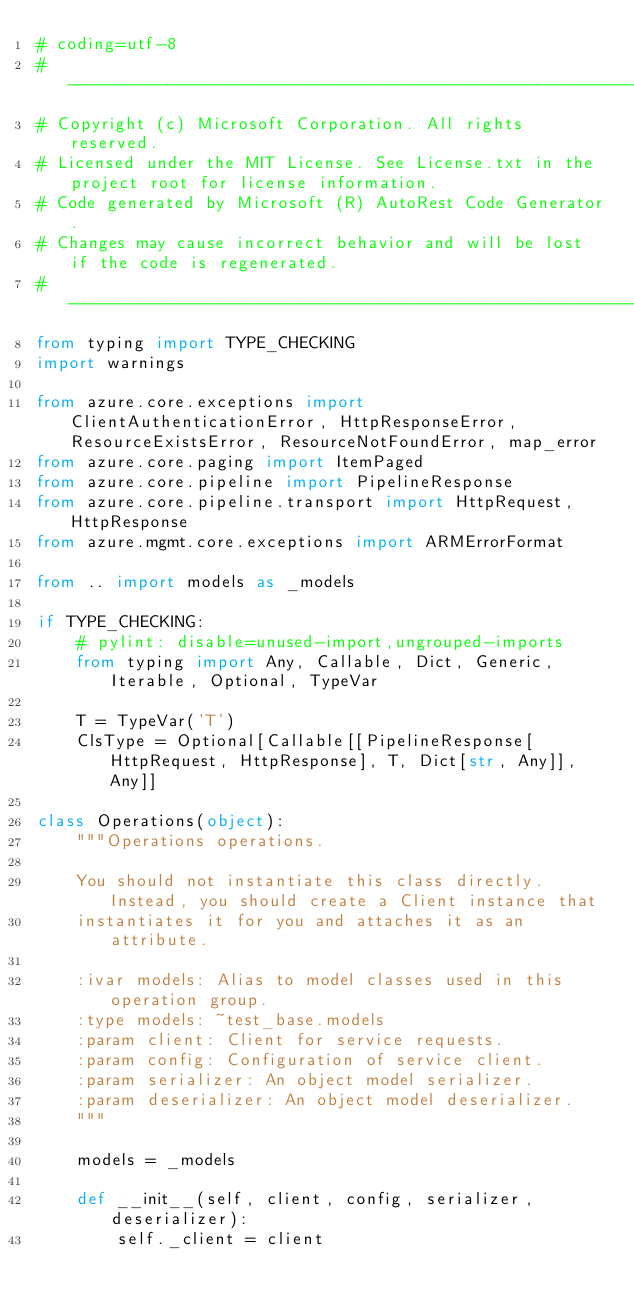Convert code to text. <code><loc_0><loc_0><loc_500><loc_500><_Python_># coding=utf-8
# --------------------------------------------------------------------------
# Copyright (c) Microsoft Corporation. All rights reserved.
# Licensed under the MIT License. See License.txt in the project root for license information.
# Code generated by Microsoft (R) AutoRest Code Generator.
# Changes may cause incorrect behavior and will be lost if the code is regenerated.
# --------------------------------------------------------------------------
from typing import TYPE_CHECKING
import warnings

from azure.core.exceptions import ClientAuthenticationError, HttpResponseError, ResourceExistsError, ResourceNotFoundError, map_error
from azure.core.paging import ItemPaged
from azure.core.pipeline import PipelineResponse
from azure.core.pipeline.transport import HttpRequest, HttpResponse
from azure.mgmt.core.exceptions import ARMErrorFormat

from .. import models as _models

if TYPE_CHECKING:
    # pylint: disable=unused-import,ungrouped-imports
    from typing import Any, Callable, Dict, Generic, Iterable, Optional, TypeVar

    T = TypeVar('T')
    ClsType = Optional[Callable[[PipelineResponse[HttpRequest, HttpResponse], T, Dict[str, Any]], Any]]

class Operations(object):
    """Operations operations.

    You should not instantiate this class directly. Instead, you should create a Client instance that
    instantiates it for you and attaches it as an attribute.

    :ivar models: Alias to model classes used in this operation group.
    :type models: ~test_base.models
    :param client: Client for service requests.
    :param config: Configuration of service client.
    :param serializer: An object model serializer.
    :param deserializer: An object model deserializer.
    """

    models = _models

    def __init__(self, client, config, serializer, deserializer):
        self._client = client</code> 